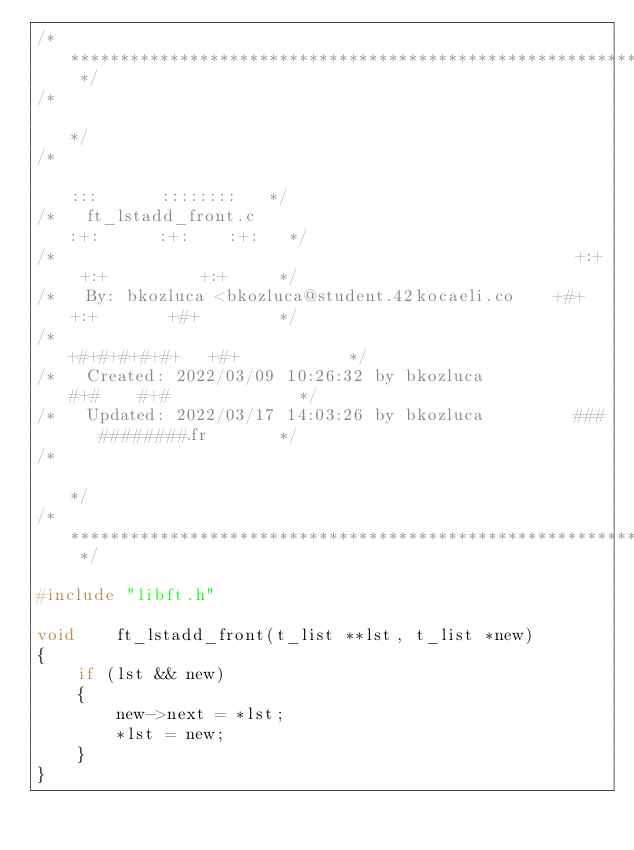<code> <loc_0><loc_0><loc_500><loc_500><_C_>/* ************************************************************************** */
/*                                                                            */
/*                                                        :::      ::::::::   */
/*   ft_lstadd_front.c                                  :+:      :+:    :+:   */
/*                                                    +:+ +:+         +:+     */
/*   By: bkozluca <bkozluca@student.42kocaeli.co    +#+  +:+       +#+        */
/*                                                +#+#+#+#+#+   +#+           */
/*   Created: 2022/03/09 10:26:32 by bkozluca          #+#    #+#             */
/*   Updated: 2022/03/17 14:03:26 by bkozluca         ###   ########.fr       */
/*                                                                            */
/* ************************************************************************** */

#include "libft.h"

void	ft_lstadd_front(t_list **lst, t_list *new)
{
	if (lst && new)
	{
		new->next = *lst;
		*lst = new;
	}
}
</code> 